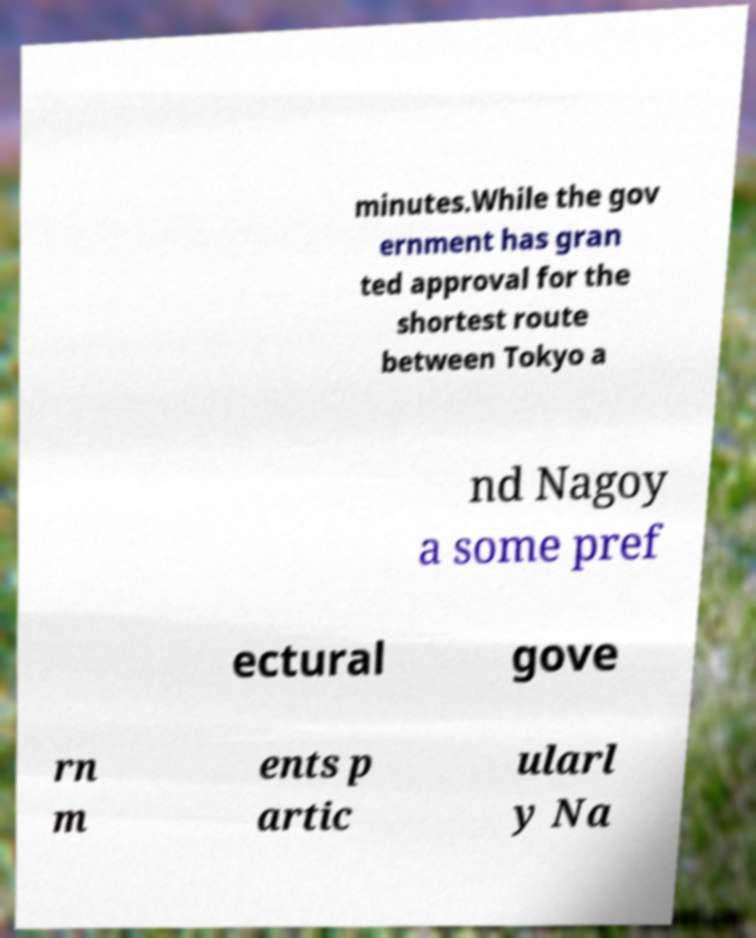Please identify and transcribe the text found in this image. minutes.While the gov ernment has gran ted approval for the shortest route between Tokyo a nd Nagoy a some pref ectural gove rn m ents p artic ularl y Na 